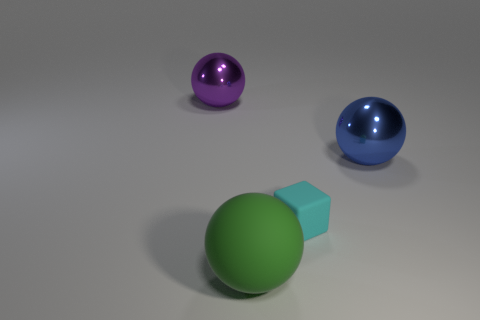Subtract all red cubes. Subtract all green cylinders. How many cubes are left? 1 Add 1 big purple metallic objects. How many objects exist? 5 Subtract all balls. How many objects are left? 1 Add 3 large rubber objects. How many large rubber objects are left? 4 Add 1 purple shiny balls. How many purple shiny balls exist? 2 Subtract 0 brown blocks. How many objects are left? 4 Subtract all big purple shiny things. Subtract all small gray rubber cubes. How many objects are left? 3 